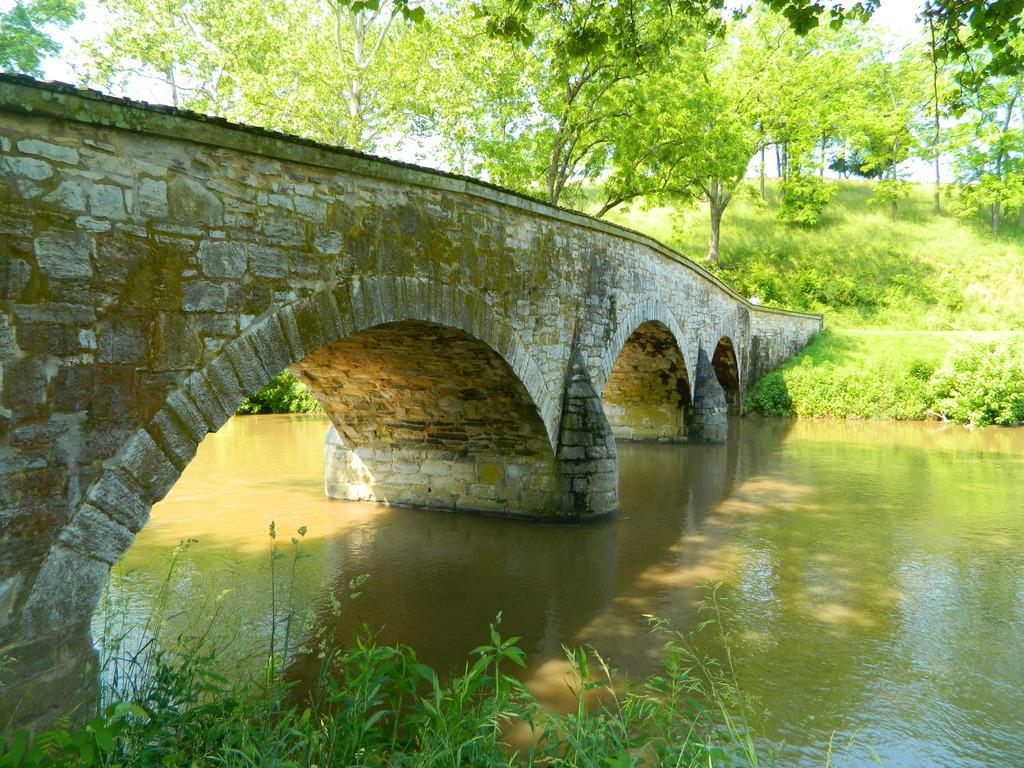What is the primary element visible in the image? There is water in the image. What structure can be seen crossing over the water? There is a bridge in the image. What type of vegetation is present in the image? There is grass and trees in the image. Can you describe the presence of shadows in the image? There are shadows visible in the image. What action is the mom performing with the roll in the image? There is no mom or roll present in the image. 